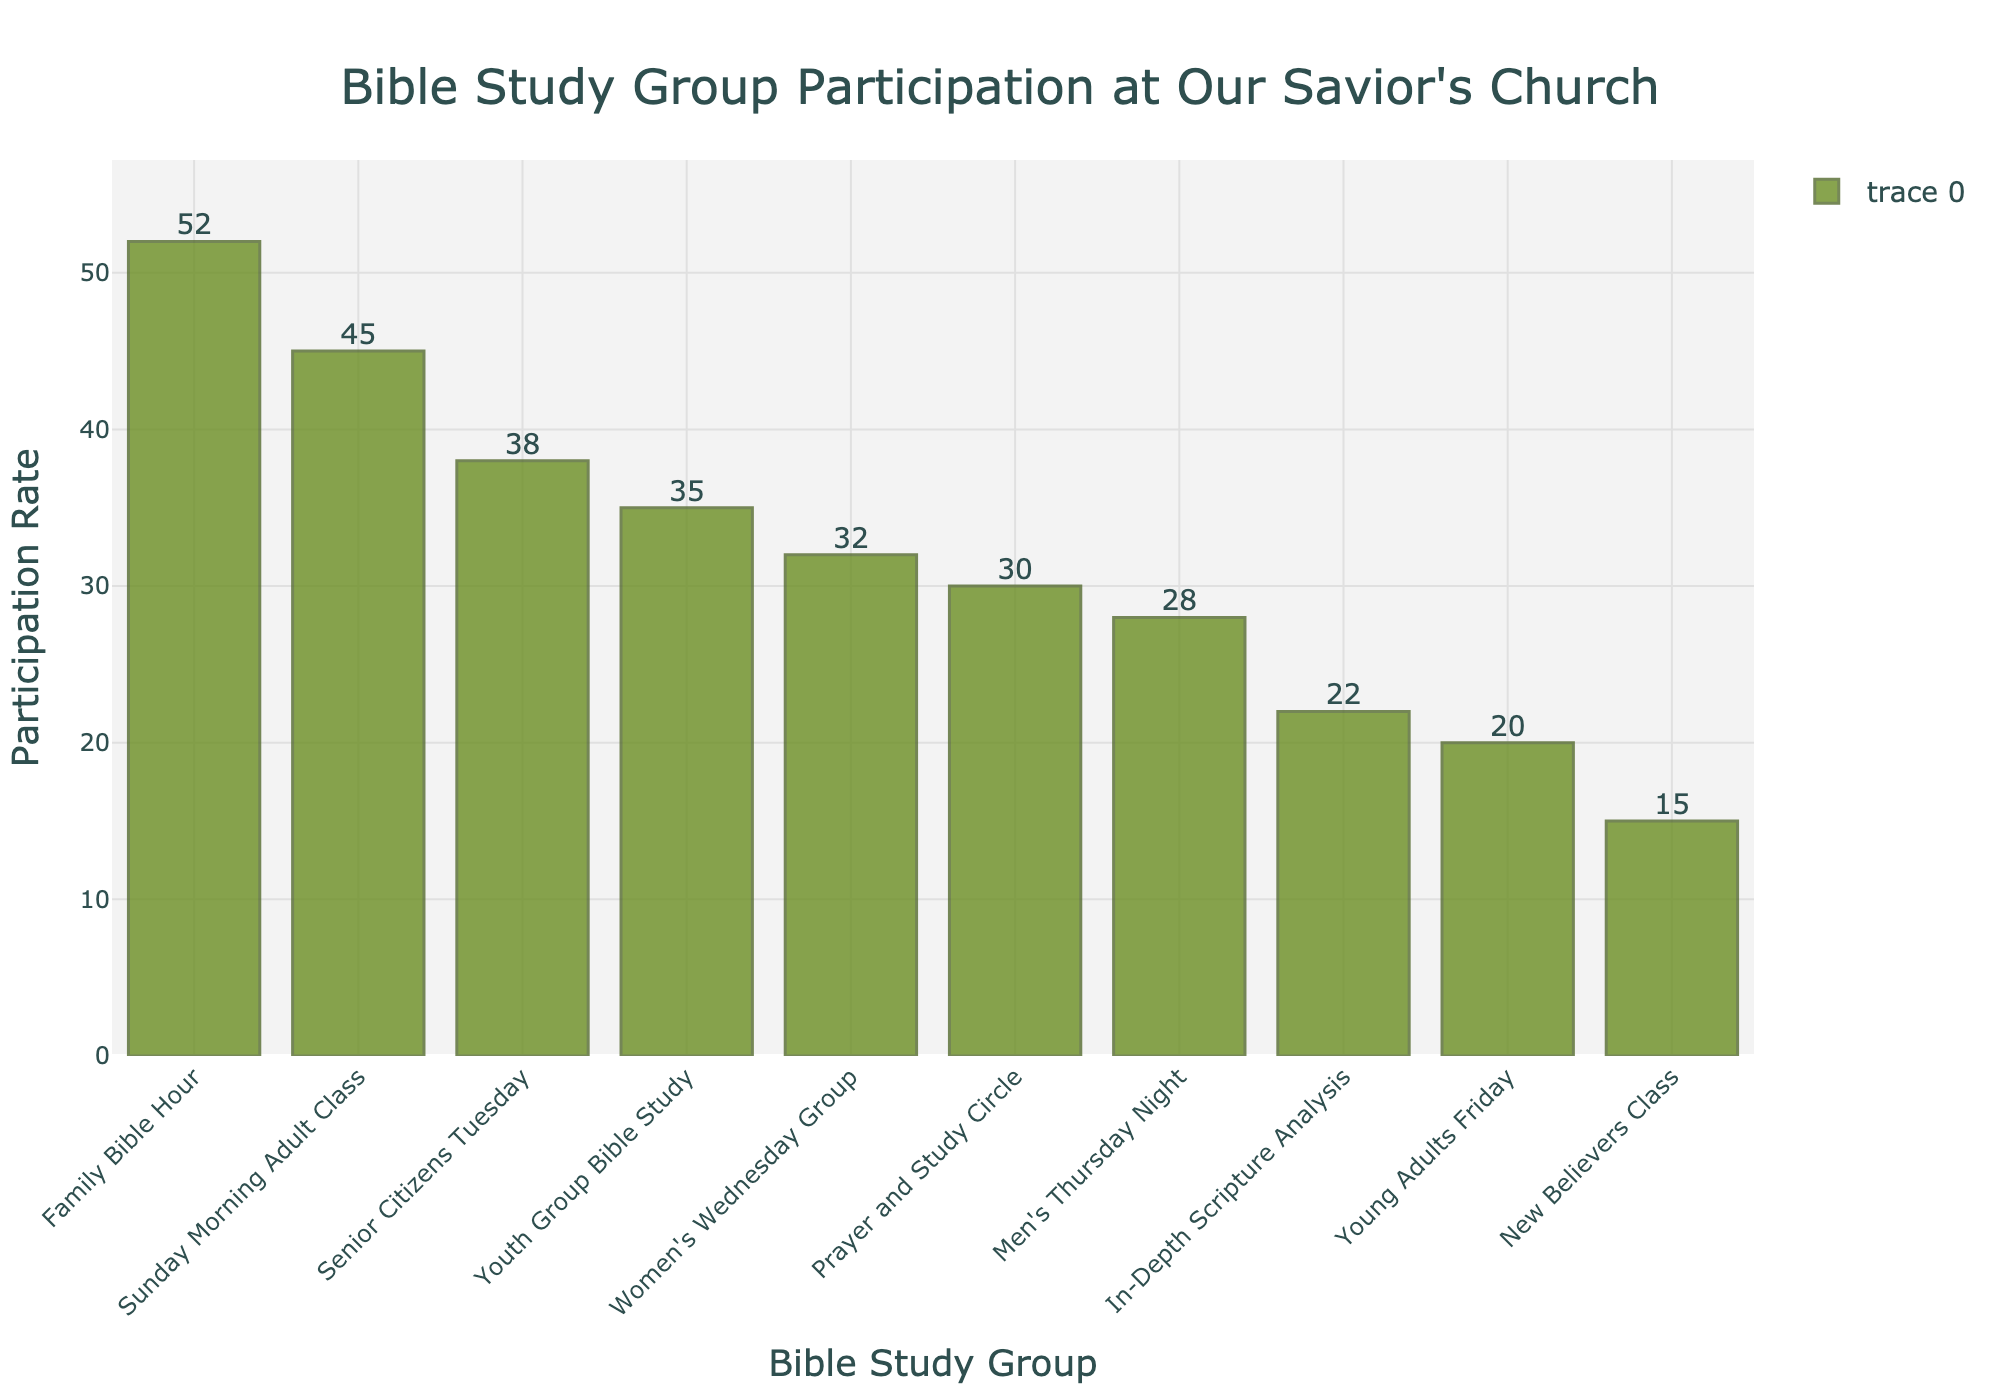What is the participation rate for the Family Bible Hour? The participation rate can be read directly from the bar for the Family Bible Hour, which is the tallest bar at 52.
Answer: 52 Which Bible study group has the lowest participation rate? The bar for the New Believers Class is the shortest, indicating that it has the lowest participation rate at 15.
Answer: New Believers Class How many more participants are in the Family Bible Hour compared to the Young Adults Friday group? The Family Bible Hour has a participation rate of 52, and the Young Adults Friday group has 20. The difference is 52 - 20 = 32.
Answer: 32 What is the total participation rate for the Men's Thursday Night and Women's Wednesday Group? The Men's Thursday Night group has a participation rate of 28, and the Women's Wednesday Group has 32. The sum is 28 + 32 = 60.
Answer: 60 Which group has a higher participation rate: Youth Group Bible Study or Prayer and Study Circle? The Youth Group Bible Study has a participation rate of 35, while the Prayer and Study Circle has 30. Therefore, the Youth Group Bible Study has a higher participation rate.
Answer: Youth Group Bible Study What is the combined participation rate of the three largest Bible study groups? The three largest Bible study groups by participation rate are Family Bible Hour (52), Sunday Morning Adult Class (45), and Senior Citizens Tuesday (38). The combined rate is 52 + 45 + 38 = 135.
Answer: 135 Which groups have a participation rate greater than 30 but less than 40? The groups that fall in this range are the Women's Wednesday Group (32), Senior Citizens Tuesday (38), and Youth Group Bible Study (35).
Answer: Women's Wednesday Group, Senior Citizens Tuesday, Youth Group Bible Study What is the average participation rate for all the Bible study groups? To find the average, sum all the participation rates and divide by the number of groups. The total participation is 45 + 32 + 28 + 20 + 38 + 52 + 15 + 22 + 30 + 35 = 317. There are 10 groups, so the average is 317 / 10 = 31.7.
Answer: 31.7 How many groups have a participation rate less than 25? The groups with participation rates less than 25 are Young Adults Friday (20), New Believers Class (15), and In-Depth Scripture Analysis (22). There are 3 groups.
Answer: 3 